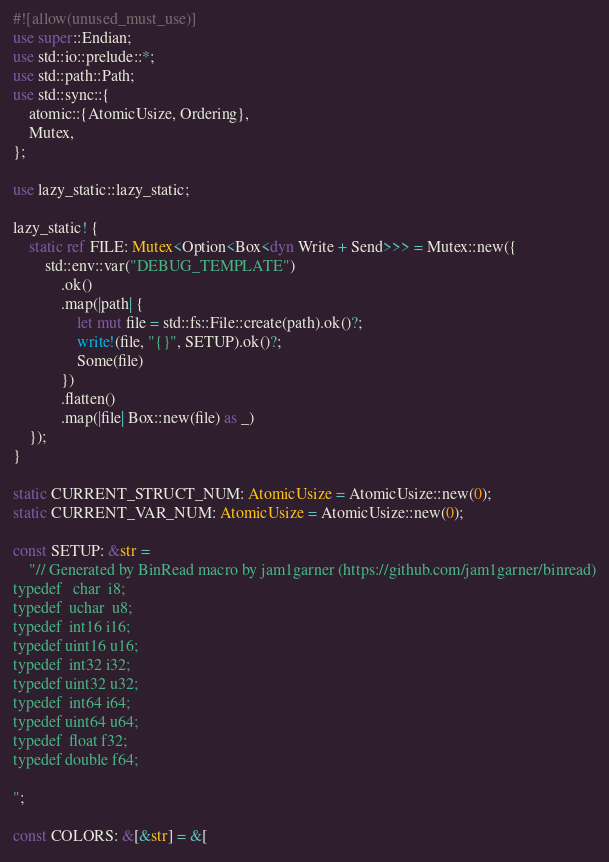<code> <loc_0><loc_0><loc_500><loc_500><_Rust_>#![allow(unused_must_use)]
use super::Endian;
use std::io::prelude::*;
use std::path::Path;
use std::sync::{
    atomic::{AtomicUsize, Ordering},
    Mutex,
};

use lazy_static::lazy_static;

lazy_static! {
    static ref FILE: Mutex<Option<Box<dyn Write + Send>>> = Mutex::new({
        std::env::var("DEBUG_TEMPLATE")
            .ok()
            .map(|path| {
                let mut file = std::fs::File::create(path).ok()?;
                write!(file, "{}", SETUP).ok()?;
                Some(file)
            })
            .flatten()
            .map(|file| Box::new(file) as _)
    });
}

static CURRENT_STRUCT_NUM: AtomicUsize = AtomicUsize::new(0);
static CURRENT_VAR_NUM: AtomicUsize = AtomicUsize::new(0);

const SETUP: &str =
    "// Generated by BinRead macro by jam1garner (https://github.com/jam1garner/binread)
typedef   char  i8;
typedef  uchar  u8;
typedef  int16 i16;
typedef uint16 u16;
typedef  int32 i32;
typedef uint32 u32;
typedef  int64 i64;
typedef uint64 u64;
typedef  float f32;
typedef double f64;

";

const COLORS: &[&str] = &[</code> 